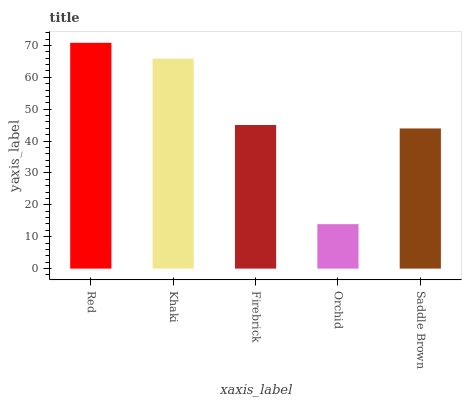Is Khaki the minimum?
Answer yes or no. No. Is Khaki the maximum?
Answer yes or no. No. Is Red greater than Khaki?
Answer yes or no. Yes. Is Khaki less than Red?
Answer yes or no. Yes. Is Khaki greater than Red?
Answer yes or no. No. Is Red less than Khaki?
Answer yes or no. No. Is Firebrick the high median?
Answer yes or no. Yes. Is Firebrick the low median?
Answer yes or no. Yes. Is Red the high median?
Answer yes or no. No. Is Orchid the low median?
Answer yes or no. No. 